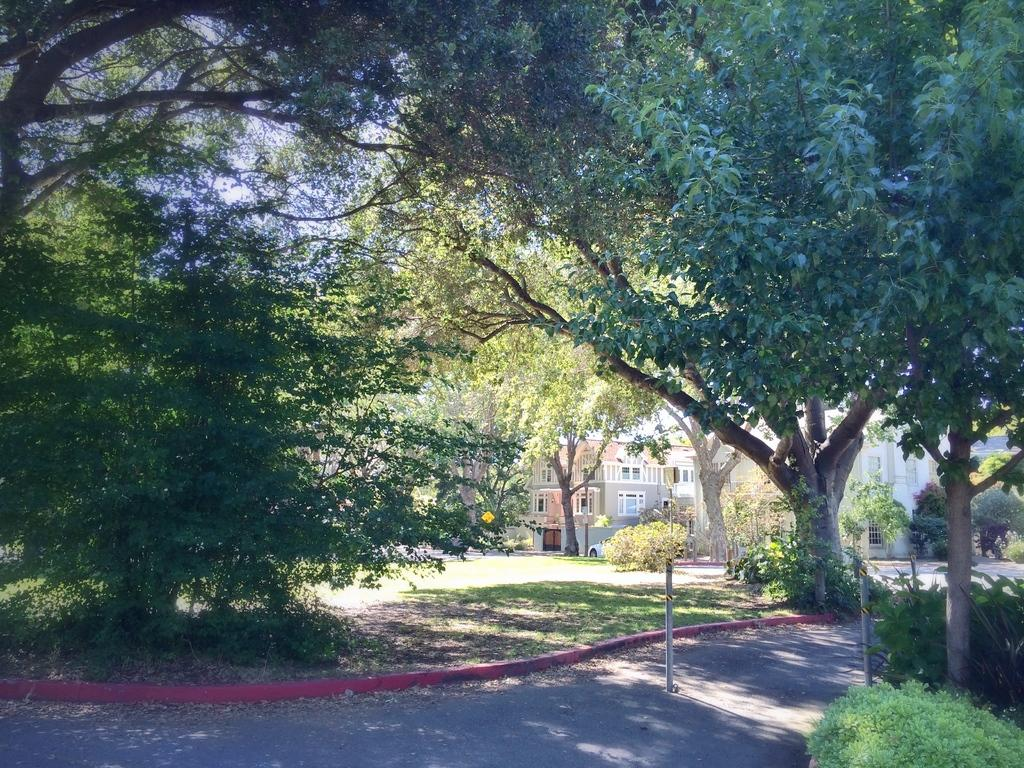What is the main feature of the image? There is a road in the image. What can be seen alongside the road? Trees are visible in the image. What is visible in the background of the image? There are buildings in the background of the image. Can you describe the position of the car in the image? There is a car in front of a building in the image. What type of cast can be seen on the car's front wheel in the image? There is no cast visible on the car's front wheel in the image. How many mittens are hanging on the tree in the image? There are no mittens present in the image. 